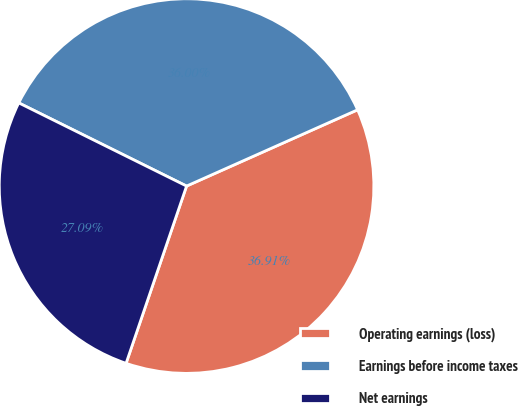Convert chart to OTSL. <chart><loc_0><loc_0><loc_500><loc_500><pie_chart><fcel>Operating earnings (loss)<fcel>Earnings before income taxes<fcel>Net earnings<nl><fcel>36.91%<fcel>36.0%<fcel>27.09%<nl></chart> 